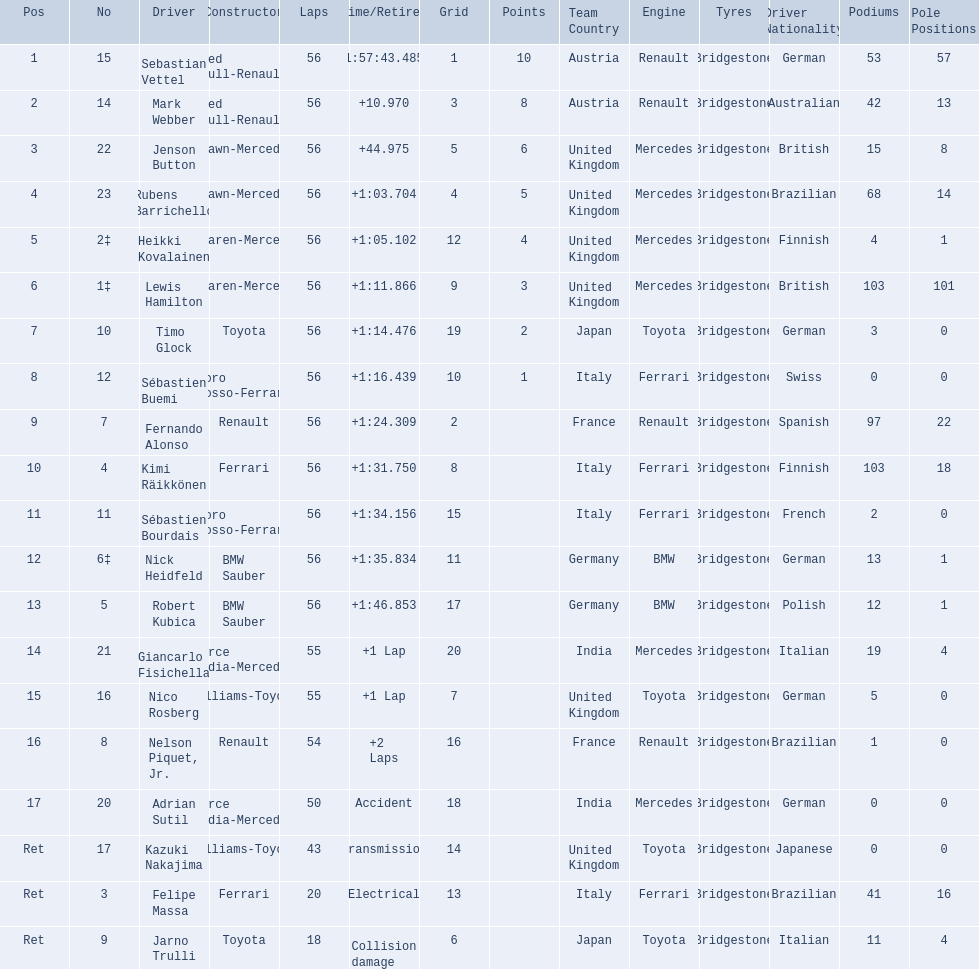Who were the drivers at the 2009 chinese grand prix? Sebastian Vettel, Mark Webber, Jenson Button, Rubens Barrichello, Heikki Kovalainen, Lewis Hamilton, Timo Glock, Sébastien Buemi, Fernando Alonso, Kimi Räikkönen, Sébastien Bourdais, Nick Heidfeld, Robert Kubica, Giancarlo Fisichella, Nico Rosberg, Nelson Piquet, Jr., Adrian Sutil, Kazuki Nakajima, Felipe Massa, Jarno Trulli. Who had the slowest time? Robert Kubica. 